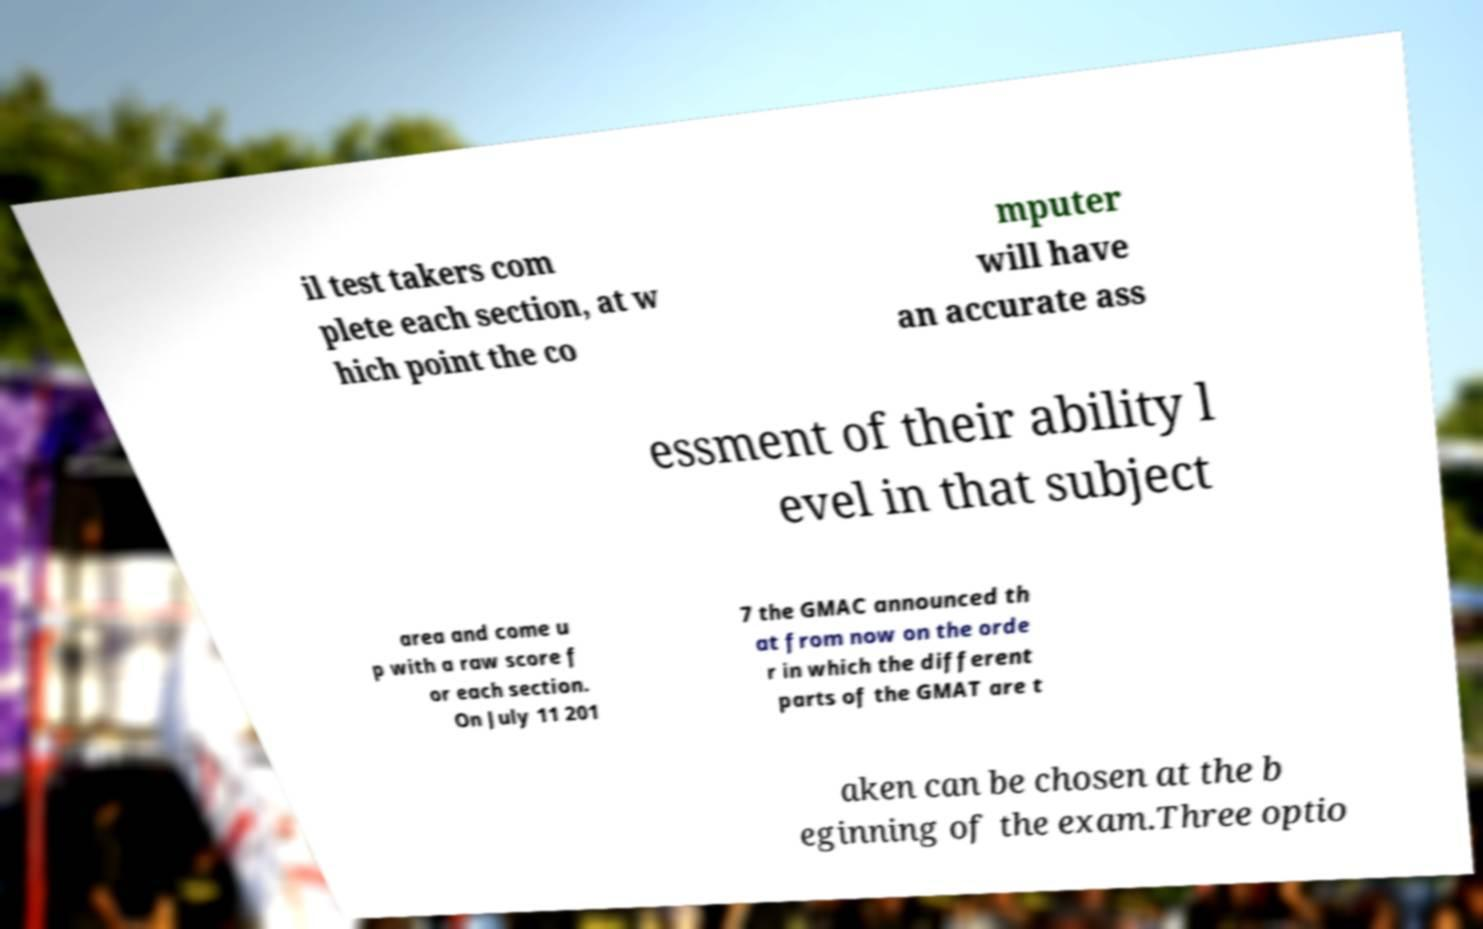Could you extract and type out the text from this image? il test takers com plete each section, at w hich point the co mputer will have an accurate ass essment of their ability l evel in that subject area and come u p with a raw score f or each section. On July 11 201 7 the GMAC announced th at from now on the orde r in which the different parts of the GMAT are t aken can be chosen at the b eginning of the exam.Three optio 